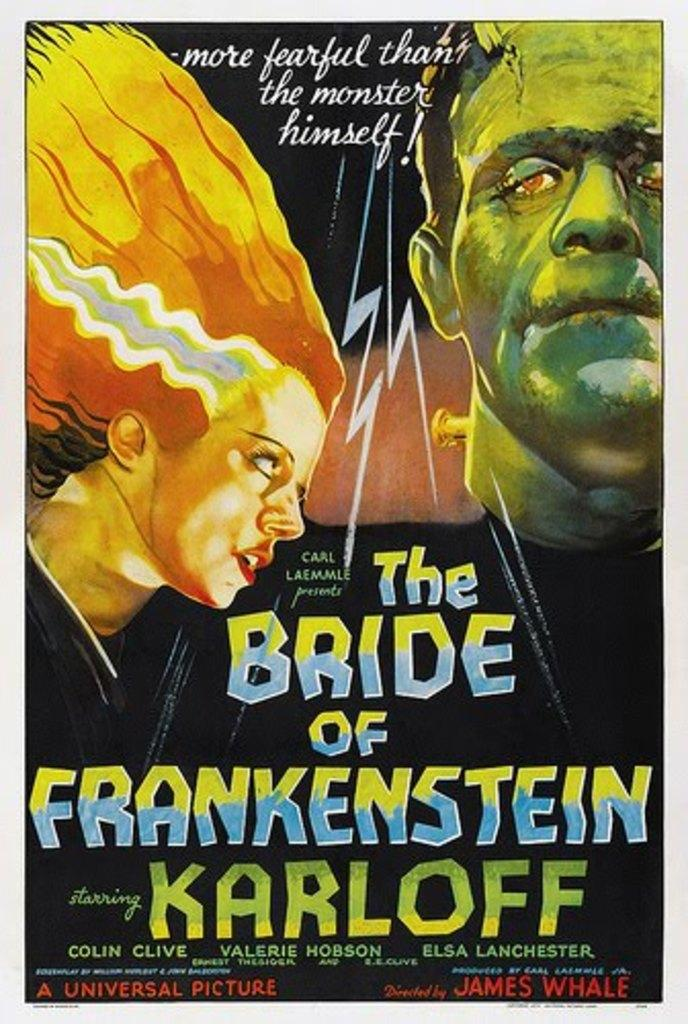<image>
Provide a brief description of the given image. The cover of the movie The Bride of Frankenstien. 